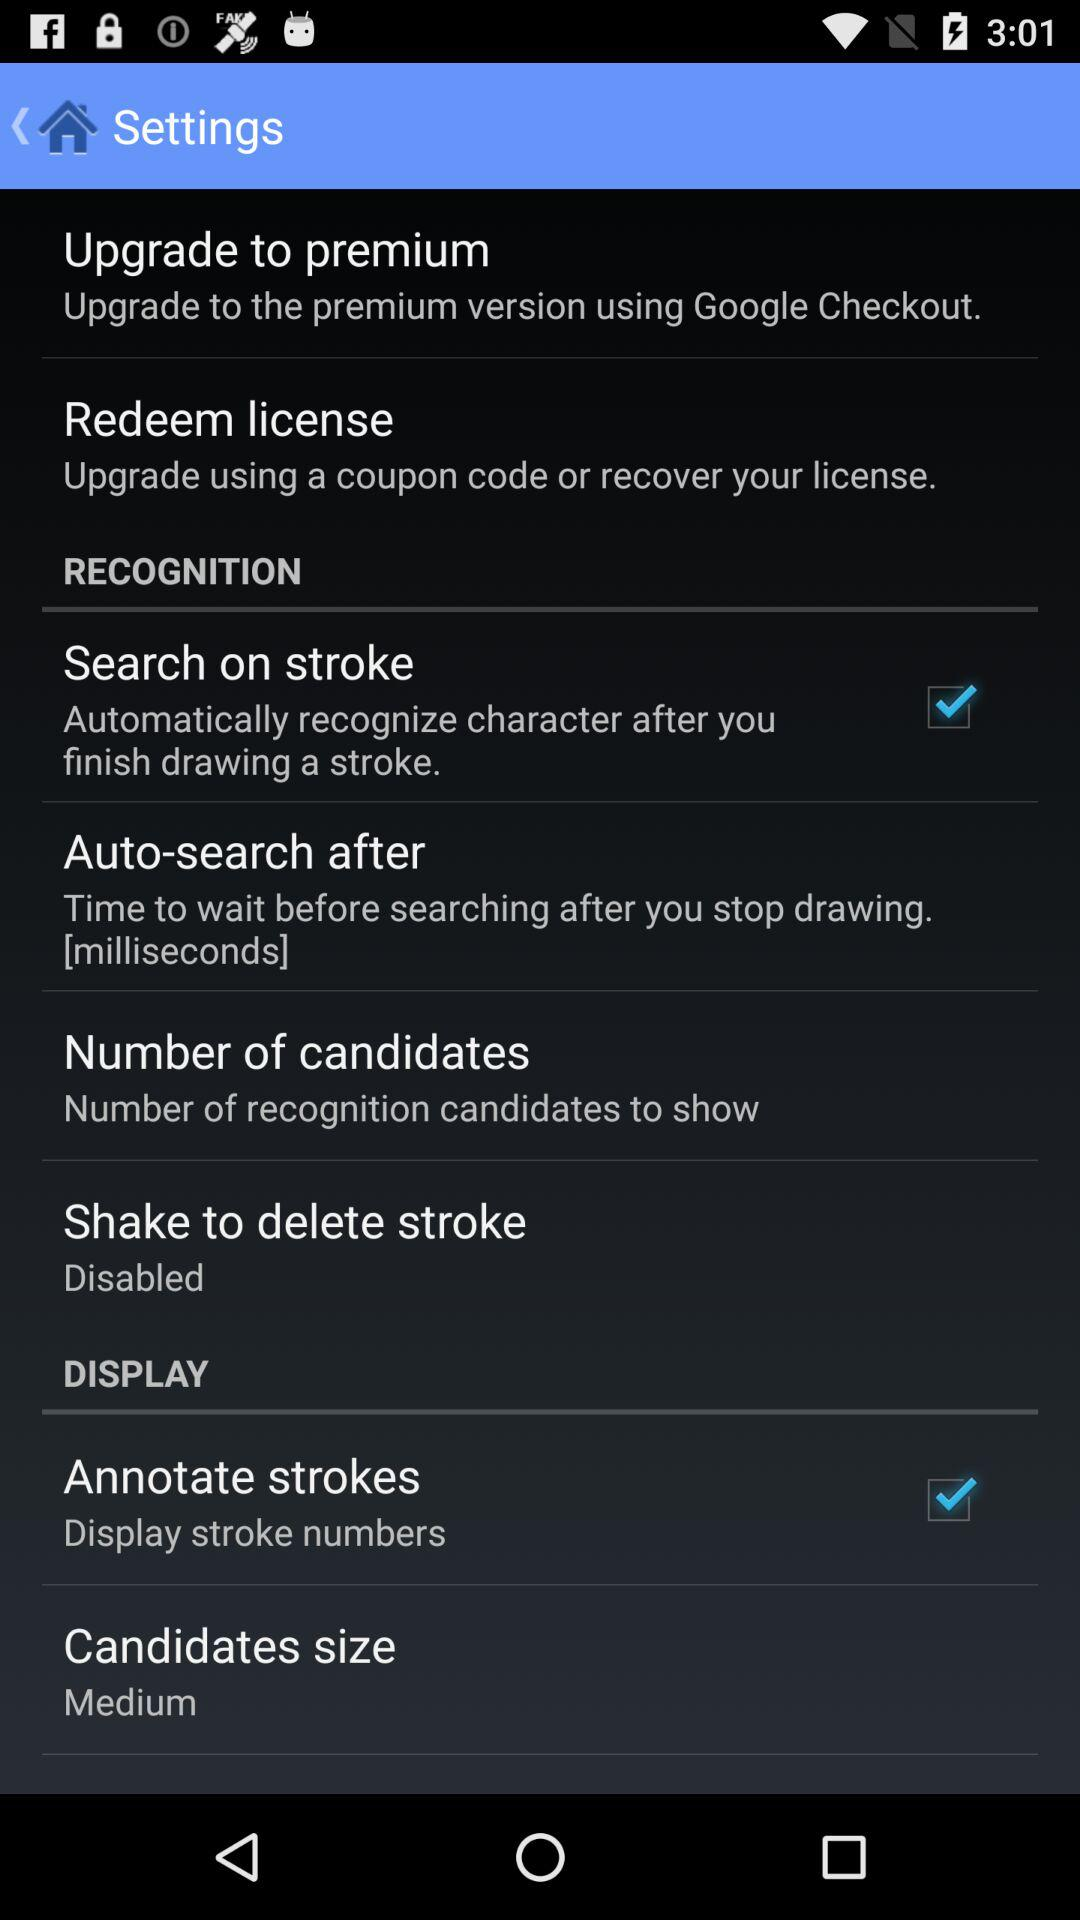What is the status of "Search on stroke"? The status of "Search on stroke" is "on". 